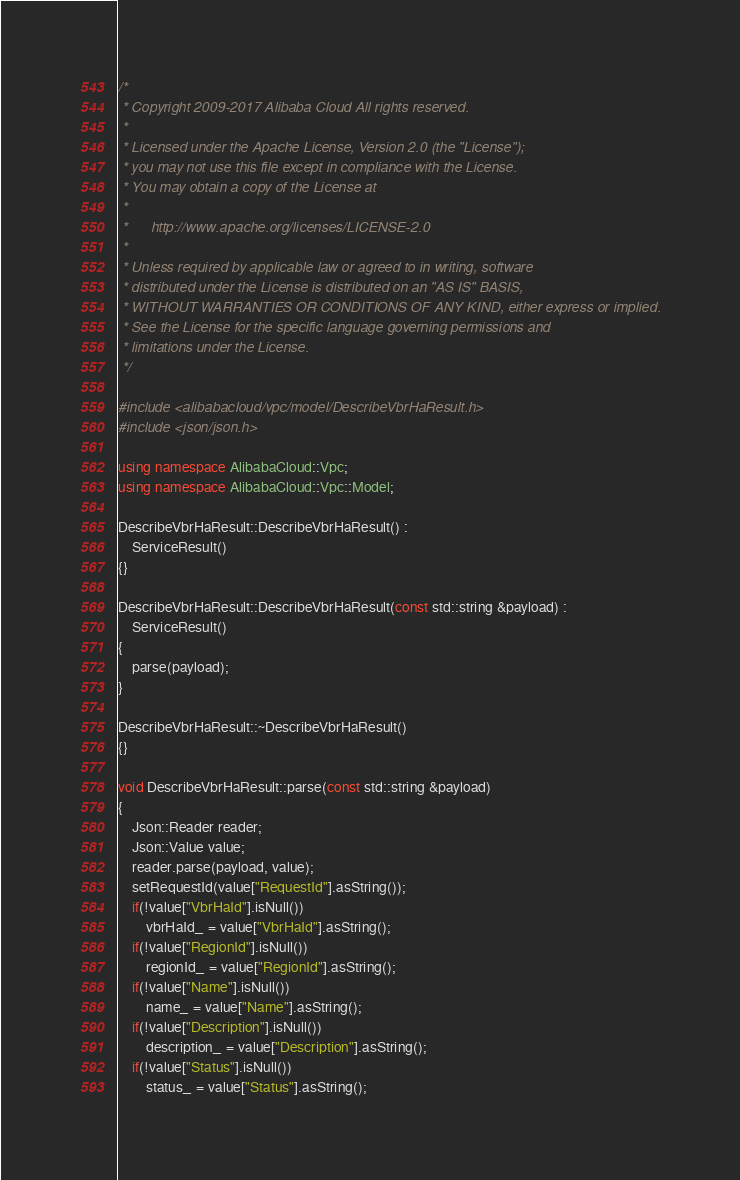Convert code to text. <code><loc_0><loc_0><loc_500><loc_500><_C++_>/*
 * Copyright 2009-2017 Alibaba Cloud All rights reserved.
 * 
 * Licensed under the Apache License, Version 2.0 (the "License");
 * you may not use this file except in compliance with the License.
 * You may obtain a copy of the License at
 * 
 *      http://www.apache.org/licenses/LICENSE-2.0
 * 
 * Unless required by applicable law or agreed to in writing, software
 * distributed under the License is distributed on an "AS IS" BASIS,
 * WITHOUT WARRANTIES OR CONDITIONS OF ANY KIND, either express or implied.
 * See the License for the specific language governing permissions and
 * limitations under the License.
 */

#include <alibabacloud/vpc/model/DescribeVbrHaResult.h>
#include <json/json.h>

using namespace AlibabaCloud::Vpc;
using namespace AlibabaCloud::Vpc::Model;

DescribeVbrHaResult::DescribeVbrHaResult() :
	ServiceResult()
{}

DescribeVbrHaResult::DescribeVbrHaResult(const std::string &payload) :
	ServiceResult()
{
	parse(payload);
}

DescribeVbrHaResult::~DescribeVbrHaResult()
{}

void DescribeVbrHaResult::parse(const std::string &payload)
{
	Json::Reader reader;
	Json::Value value;
	reader.parse(payload, value);
	setRequestId(value["RequestId"].asString());
	if(!value["VbrHaId"].isNull())
		vbrHaId_ = value["VbrHaId"].asString();
	if(!value["RegionId"].isNull())
		regionId_ = value["RegionId"].asString();
	if(!value["Name"].isNull())
		name_ = value["Name"].asString();
	if(!value["Description"].isNull())
		description_ = value["Description"].asString();
	if(!value["Status"].isNull())
		status_ = value["Status"].asString();</code> 